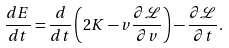Convert formula to latex. <formula><loc_0><loc_0><loc_500><loc_500>\frac { d E } { d t } = \frac { d } { d t } \left ( 2 K - v \frac { \partial \mathcal { L } } { \partial v } \right ) - \frac { \partial \mathcal { L } } { \partial t } .</formula> 